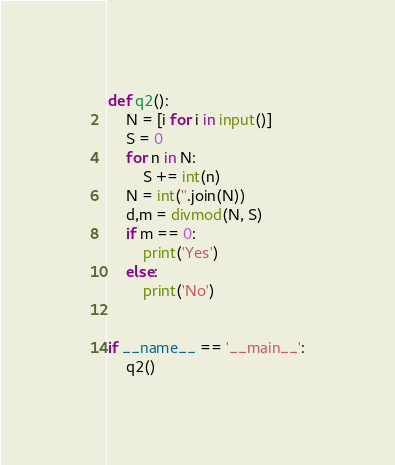Convert code to text. <code><loc_0><loc_0><loc_500><loc_500><_Python_>def q2():
    N = [i for i in input()]
    S = 0
    for n in N:
        S += int(n)
    N = int(''.join(N))
    d,m = divmod(N, S)
    if m == 0:
        print('Yes')
    else:
        print('No')


if __name__ == '__main__':
    q2()</code> 